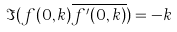<formula> <loc_0><loc_0><loc_500><loc_500>\Im ( f ( 0 , k ) \overline { f ^ { \prime } ( 0 , k ) } ) = - k</formula> 